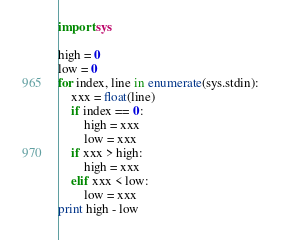<code> <loc_0><loc_0><loc_500><loc_500><_Python_>import sys

high = 0
low = 0
for index, line in enumerate(sys.stdin):
    xxx = float(line)
    if index == 0:
        high = xxx
        low = xxx
    if xxx > high:
        high = xxx
    elif xxx < low:
        low = xxx
print high - low</code> 